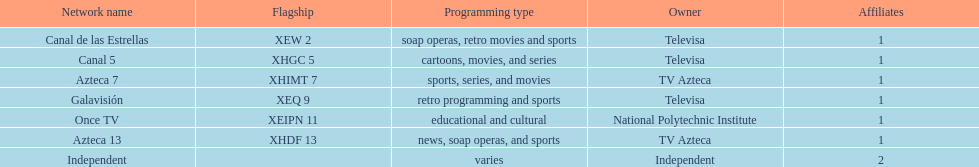What is the number of networks that are owned by televisa? 3. I'm looking to parse the entire table for insights. Could you assist me with that? {'header': ['Network name', 'Flagship', 'Programming type', 'Owner', 'Affiliates'], 'rows': [['Canal de las Estrellas', 'XEW 2', 'soap operas, retro movies and sports', 'Televisa', '1'], ['Canal 5', 'XHGC 5', 'cartoons, movies, and series', 'Televisa', '1'], ['Azteca 7', 'XHIMT 7', 'sports, series, and movies', 'TV Azteca', '1'], ['Galavisión', 'XEQ 9', 'retro programming and sports', 'Televisa', '1'], ['Once TV', 'XEIPN 11', 'educational and cultural', 'National Polytechnic Institute', '1'], ['Azteca 13', 'XHDF 13', 'news, soap operas, and sports', 'TV Azteca', '1'], ['Independent', '', 'varies', 'Independent', '2']]} 